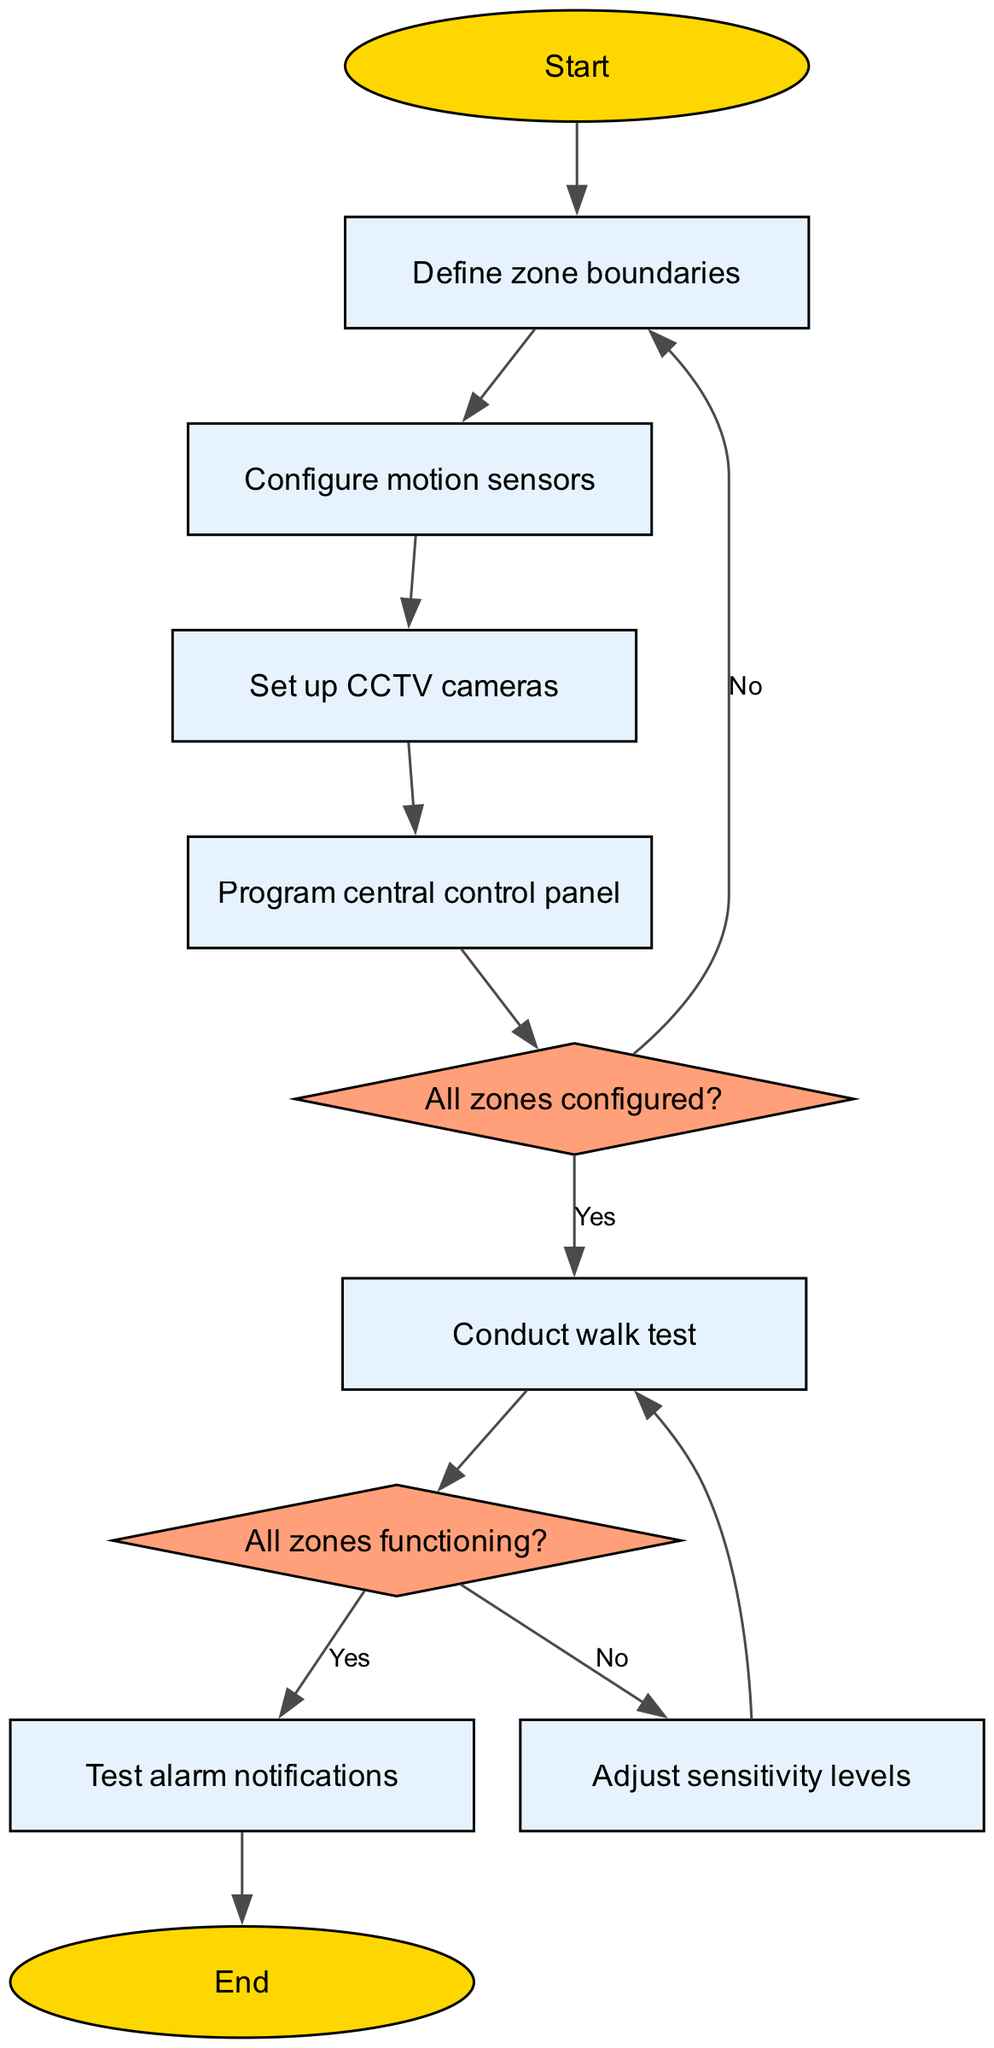What is the first step in programming the perimeter system? The diagram starts at the "Start" node, which then leads to the "Define zone boundaries" process. Thus, the first step in the flowchart is to define the zone boundaries.
Answer: Define zone boundaries How many total nodes are there in the flowchart? By counting the start, processes, decisions, and end nodes, there are a total of 10 nodes in the diagram.
Answer: 10 What happens if "All zones configured?" is answered as "No"? If the answer is "No" for "All zones configured?", the flow leads back to "Define zone boundaries" to redo that step in the process.
Answer: Define zone boundaries What is the result if "All zones functioning?" is answered as "Yes"? The flow would lead directly to the "Test alarm notifications" process, indicating that all zones are functioning correctly.
Answer: Test alarm notifications How many decision points are present in the flowchart? There are 2 decision points in the flowchart, which are "All zones configured?" and "All zones functioning?".
Answer: 2 What is the last process before the flowchart ends? The diagram shows that the final process before reaching the "End" node is "Test alarm notifications", meaning this is the last action taken before concluding the flow.
Answer: Test alarm notifications If sensitivity levels need to be adjusted, to which process would the flow return? If the flow branches from "All zones functioning?" with a "No", it leads to "Adjust sensitivity levels", then it loops back to "Conduct walk test" after adjusting.
Answer: Conduct walk test What type of shape represents a decision in the diagram? The decision nodes in the diagram are represented by diamond-shaped elements, which visually indicate a point where a decision must be made.
Answer: Diamond What is the significance of the "Conduct walk test" process? It serves as an important step to ensure that all configured zones are functioning as intended before proceeding to the notifications test.
Answer: Ensure functionality 